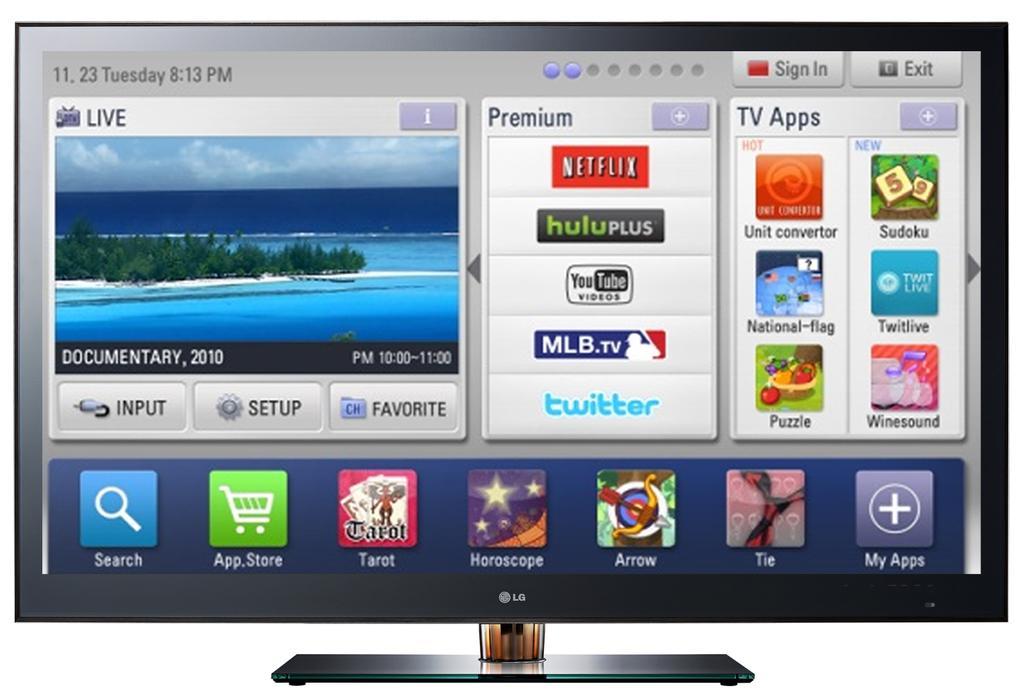Describe this image in one or two sentences. In this image, we can see monitor with stand. On the screen, we can see the image, text, icons and applications. 